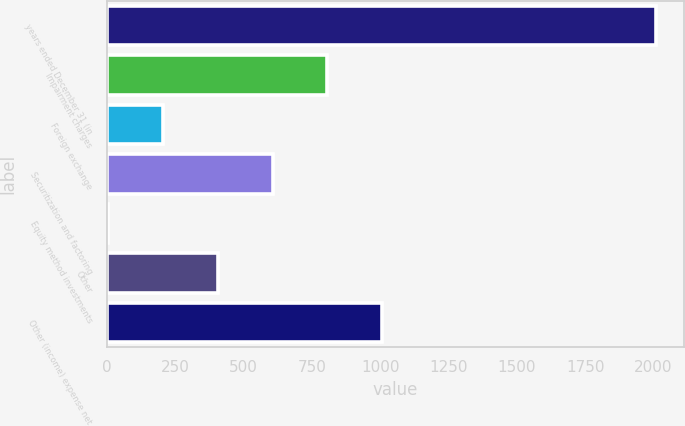Convert chart to OTSL. <chart><loc_0><loc_0><loc_500><loc_500><bar_chart><fcel>years ended December 31 (in<fcel>Impairment charges<fcel>Foreign exchange<fcel>Securitization and factoring<fcel>Equity method investments<fcel>Other<fcel>Other (income) expense net<nl><fcel>2011<fcel>806.8<fcel>204.7<fcel>606.1<fcel>4<fcel>405.4<fcel>1007.5<nl></chart> 